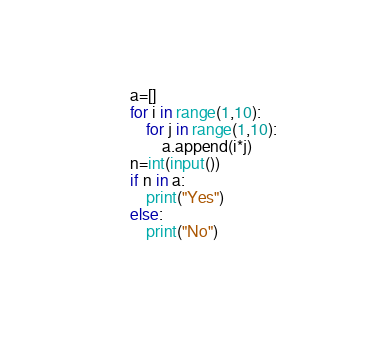<code> <loc_0><loc_0><loc_500><loc_500><_Python_>a=[]
for i in range(1,10):
    for j in range(1,10):
        a.append(i*j)
n=int(input())
if n in a:
    print("Yes")
else:
    print("No")
    </code> 